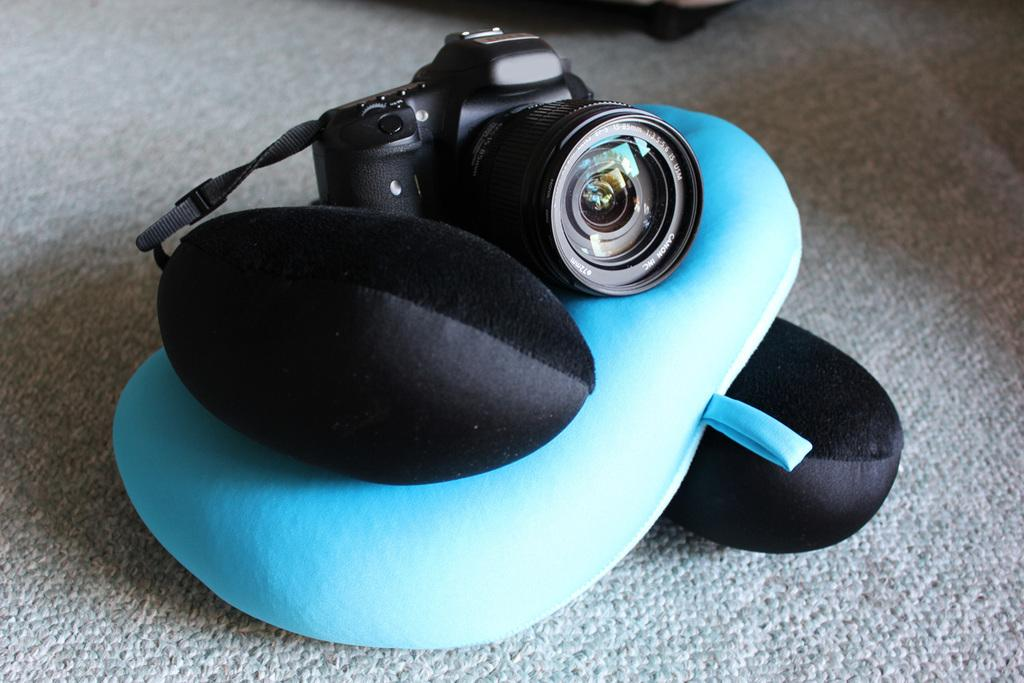What object is the main focus of the image? There is a camera in the image. Where is the camera placed? The camera is placed on a pillow. Can you describe the color of the pillow? The pillow is blue in color. Are there any other pillows visible in the image? Yes, there are two black pillows, one on the top and one at the bottom of the blue pillow. What type of lipstick is visible on the orange in the image? There is no lipstick or orange present in the image; it features a camera placed on a blue pillow with two black pillows on either side. 